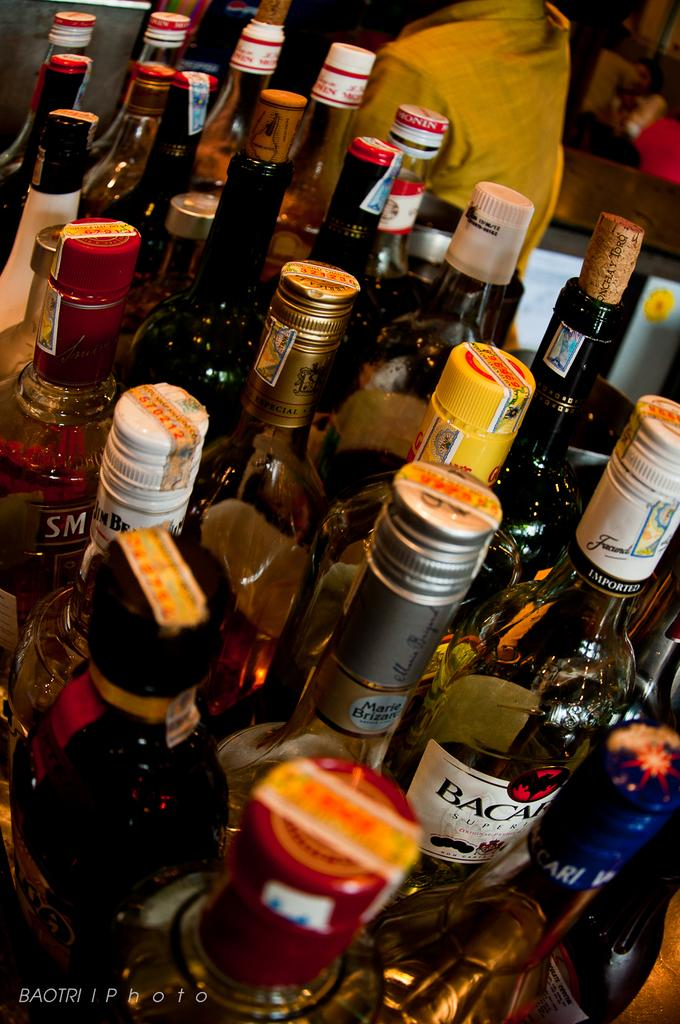<image>
Offer a succinct explanation of the picture presented. A cluster of liquor bottles including Bacardi are in a restaurant. 